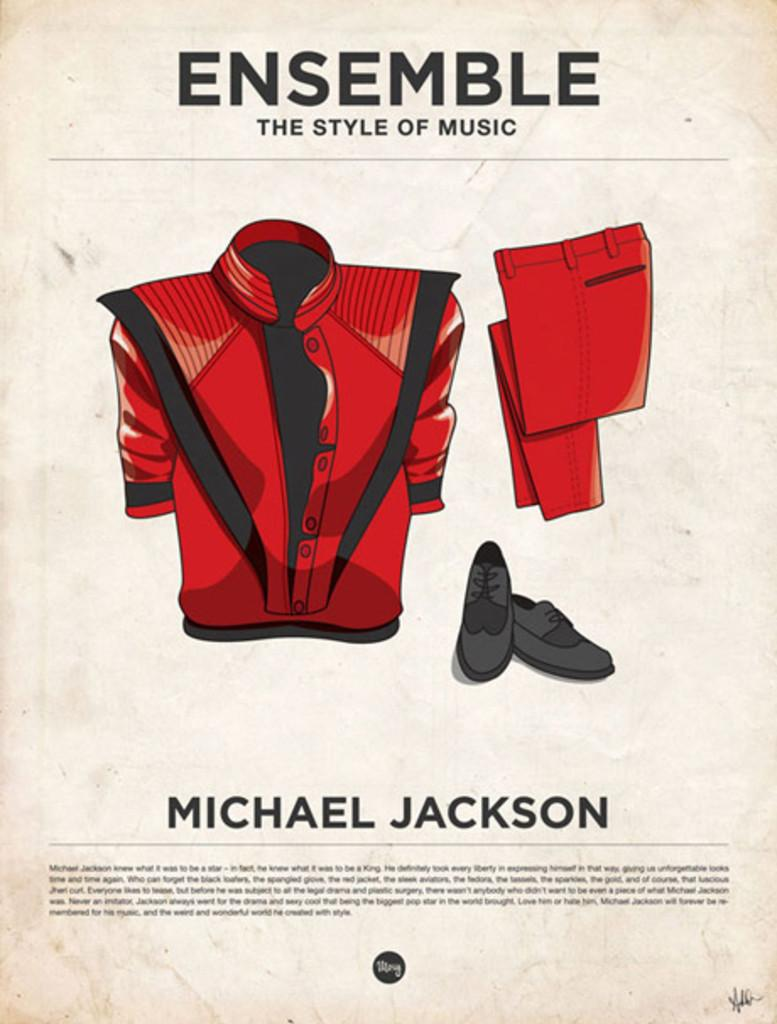<image>
Share a concise interpretation of the image provided. A page with Michael Jackson's name on it shows his famous red jacket. 